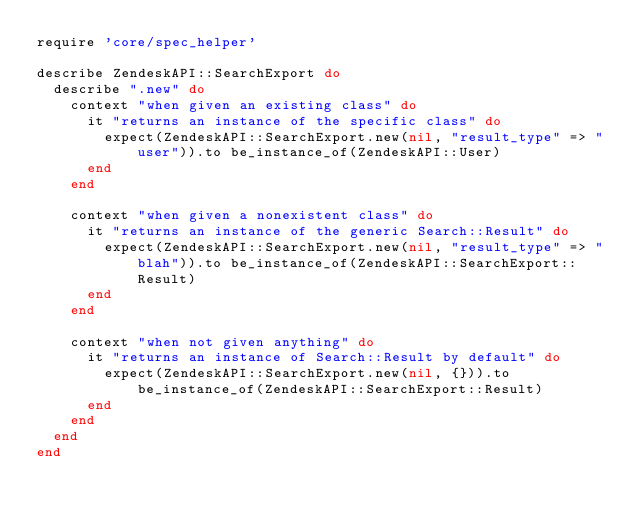Convert code to text. <code><loc_0><loc_0><loc_500><loc_500><_Ruby_>require 'core/spec_helper'

describe ZendeskAPI::SearchExport do
  describe ".new" do
    context "when given an existing class" do
      it "returns an instance of the specific class" do
        expect(ZendeskAPI::SearchExport.new(nil, "result_type" => "user")).to be_instance_of(ZendeskAPI::User)
      end
    end

    context "when given a nonexistent class" do
      it "returns an instance of the generic Search::Result" do
        expect(ZendeskAPI::SearchExport.new(nil, "result_type" => "blah")).to be_instance_of(ZendeskAPI::SearchExport::Result)
      end
    end

    context "when not given anything" do
      it "returns an instance of Search::Result by default" do
        expect(ZendeskAPI::SearchExport.new(nil, {})).to be_instance_of(ZendeskAPI::SearchExport::Result)
      end
    end
  end
end
</code> 